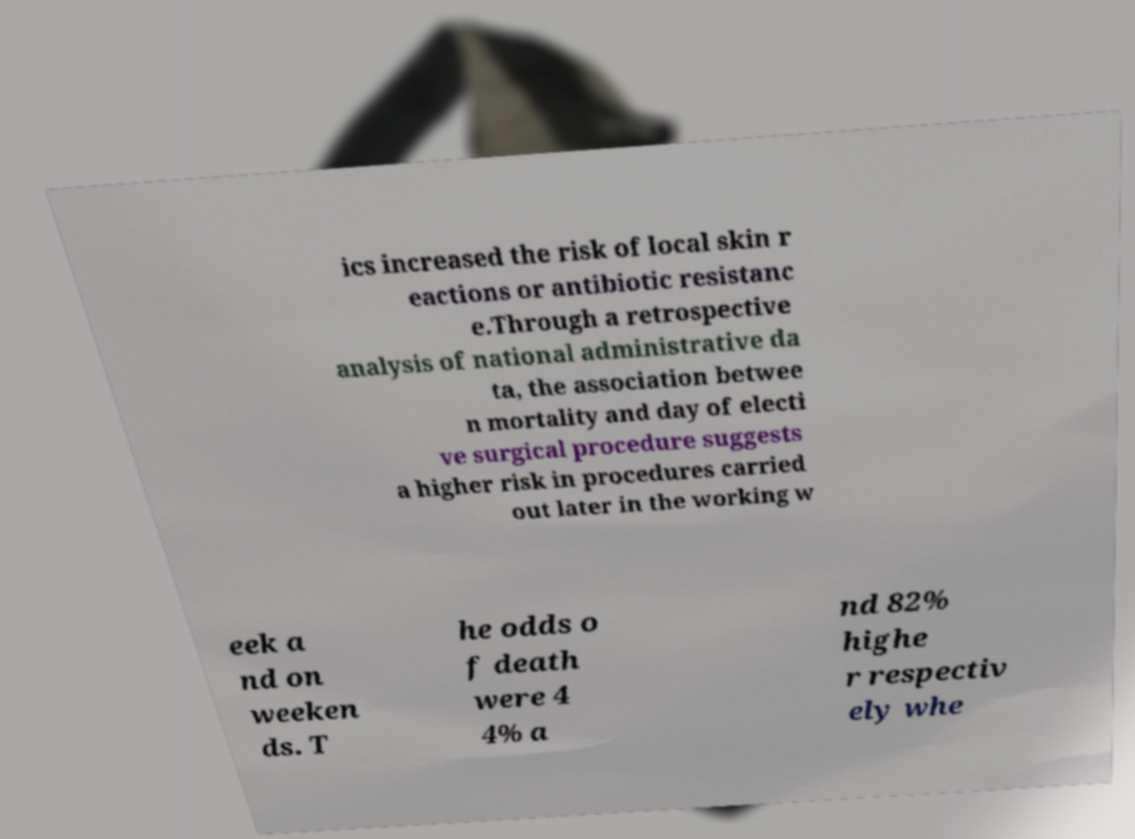For documentation purposes, I need the text within this image transcribed. Could you provide that? ics increased the risk of local skin r eactions or antibiotic resistanc e.Through a retrospective analysis of national administrative da ta, the association betwee n mortality and day of electi ve surgical procedure suggests a higher risk in procedures carried out later in the working w eek a nd on weeken ds. T he odds o f death were 4 4% a nd 82% highe r respectiv ely whe 